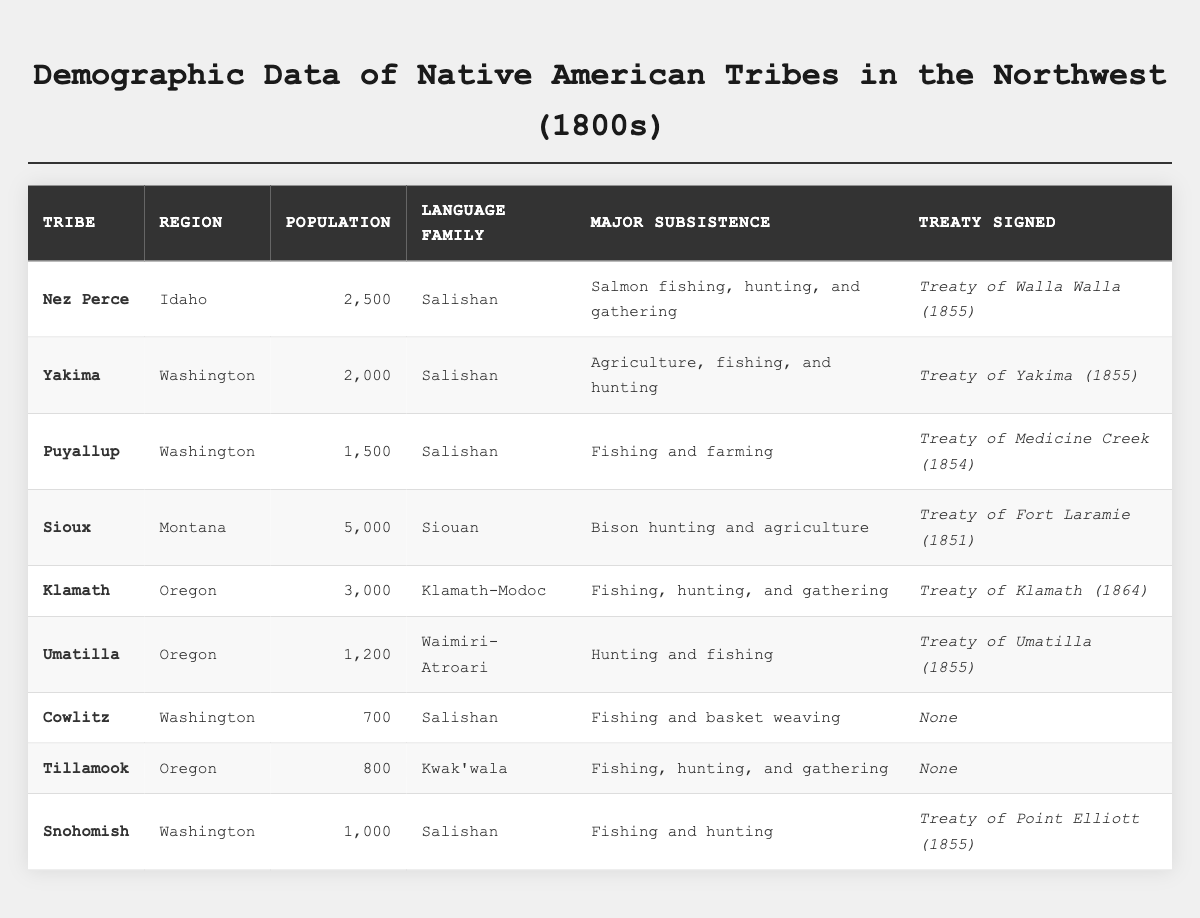What is the population of the Nez Perce tribe? The table shows that the population of the Nez Perce tribe is listed in the "Population (1800s)" column, which states 2,500.
Answer: 2,500 Which tribe has the smallest population? By comparing the population figures for all tribes listed, the Cowlitz tribe has the smallest population at 700.
Answer: Cowlitz How many tribes signed treaties in 1855? The table lists the treaties signed along with the years; counting the tribes with "1855" results in four tribes: Nez Perce, Yakima, Umatilla, and Snohomish.
Answer: 4 What is the total population of all the tribes from Oregon? The populations of the tribes from Oregon are Klamath (3,000) and Umatilla (1,200). Adding these populations gives: 3,000 + 1,200 = 4,200.
Answer: 4,200 Which language family has the most tribes represented? The Salishan language family includes Nez Perce, Yakima, Puyallup, Cowlitz, and Snohomish, totaling five tribes, while other families have fewer tribes.
Answer: Salishan Is there any tribe that did not sign a treaty? Looking at the "Treaty Signed" column, both Cowlitz and Tillamook are listed as "None," indicating they did not sign a treaty.
Answer: Yes What is the average population of the tribes listed in Washington? The tribes from Washington are Yakima (2,000), Puyallup (1,500), Cowlitz (700), and Snohomish (1,000). Adding these populations results in 2,000 + 1,500 + 700 + 1,000 = 5,200, and there are 4 tribes. So, the average is 5,200 / 4 = 1,300.
Answer: 1,300 Which tribe has the highest population, and what is that population? The Sioux tribe has the highest population of 5,000, as evident from the population column.
Answer: Sioux, 5,000 What are the major subsistence activities of the Yakima tribe? Referring to the table, the major subsistence for the Yakima tribe is listed as agriculture, fishing, and hunting.
Answer: Agriculture, fishing, and hunting How many tribes have fishing as a major subsistence activity? By reviewing the "Major Subsistence" column, the tribes with fishing noted are Nez Perce, Puyallup, Klamath, Umatilla, Cowlitz, Tillamook, and Snohomish, totaling six tribes.
Answer: 6 Do any tribes have the same language family? The Salishan language family is shared among several tribes including Nez Perce, Yakima, Puyallup, Cowlitz, and Snohomish, indicating multiple tribes share this family.
Answer: Yes 